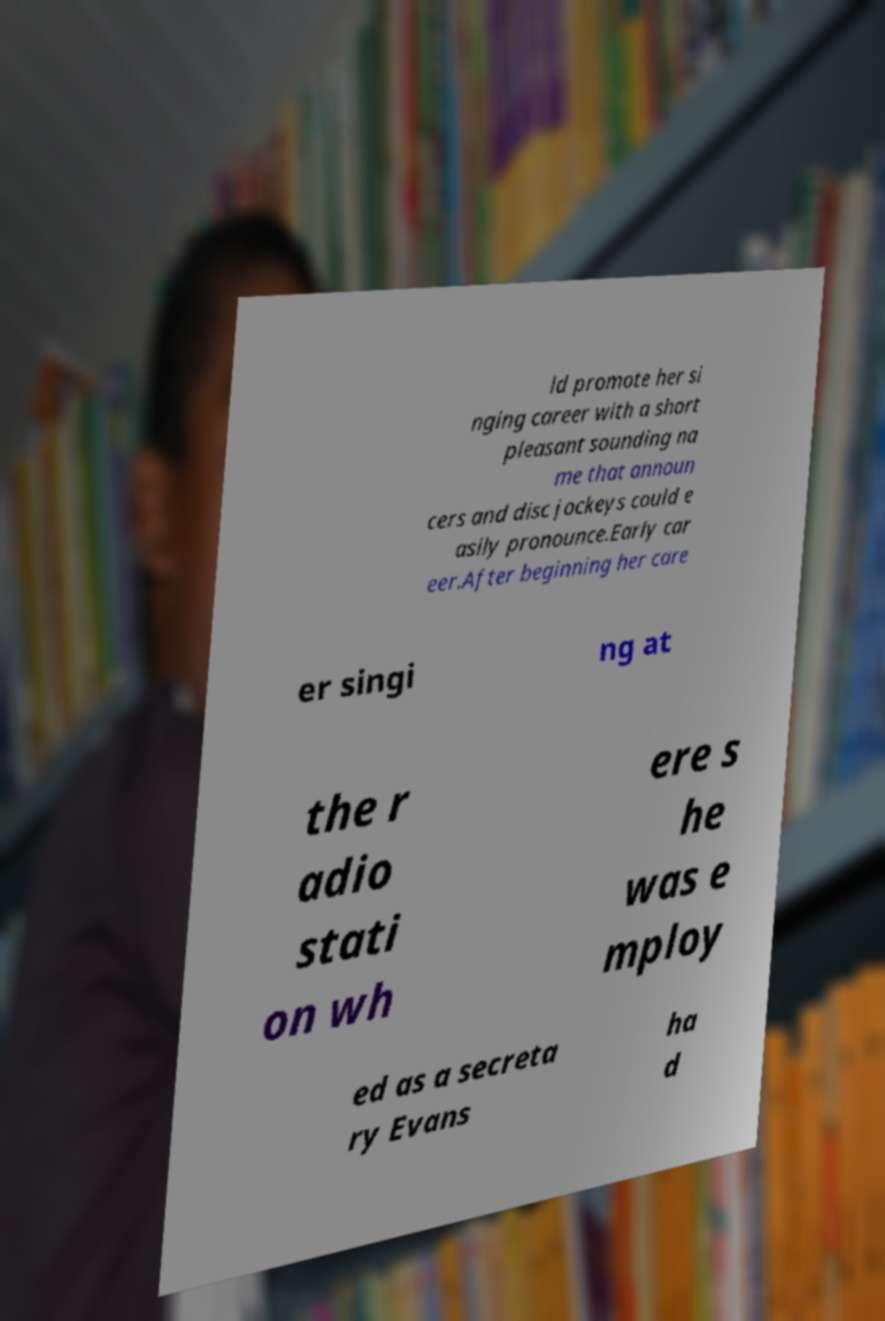I need the written content from this picture converted into text. Can you do that? ld promote her si nging career with a short pleasant sounding na me that announ cers and disc jockeys could e asily pronounce.Early car eer.After beginning her care er singi ng at the r adio stati on wh ere s he was e mploy ed as a secreta ry Evans ha d 